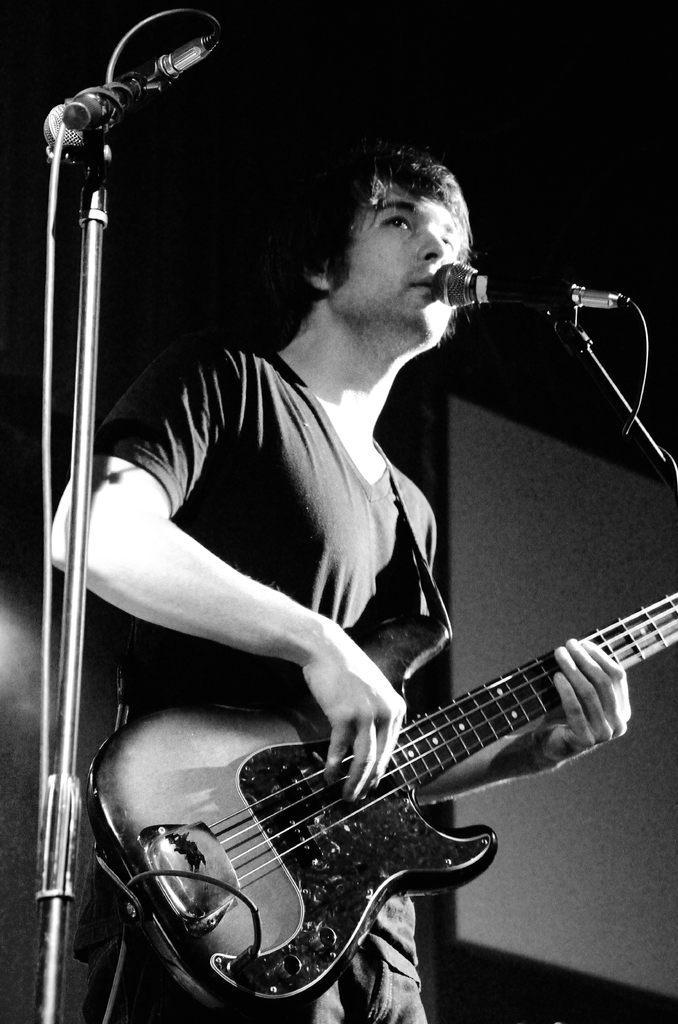Describe this image in one or two sentences. A man is singing with a mic and playing a guitar. 